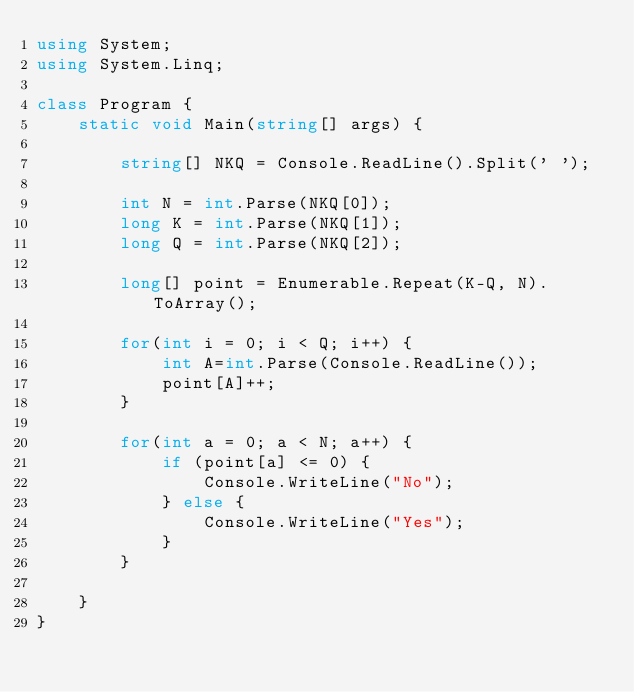<code> <loc_0><loc_0><loc_500><loc_500><_C#_>using System;
using System.Linq;

class Program {
    static void Main(string[] args) {

        string[] NKQ = Console.ReadLine().Split(' ');

        int N = int.Parse(NKQ[0]);
        long K = int.Parse(NKQ[1]);
        long Q = int.Parse(NKQ[2]);

        long[] point = Enumerable.Repeat(K-Q, N).ToArray();

        for(int i = 0; i < Q; i++) {
            int A=int.Parse(Console.ReadLine());
            point[A]++;
        }

        for(int a = 0; a < N; a++) {
            if (point[a] <= 0) {
                Console.WriteLine("No");
            } else {
                Console.WriteLine("Yes");
            }
        }

    }
}</code> 